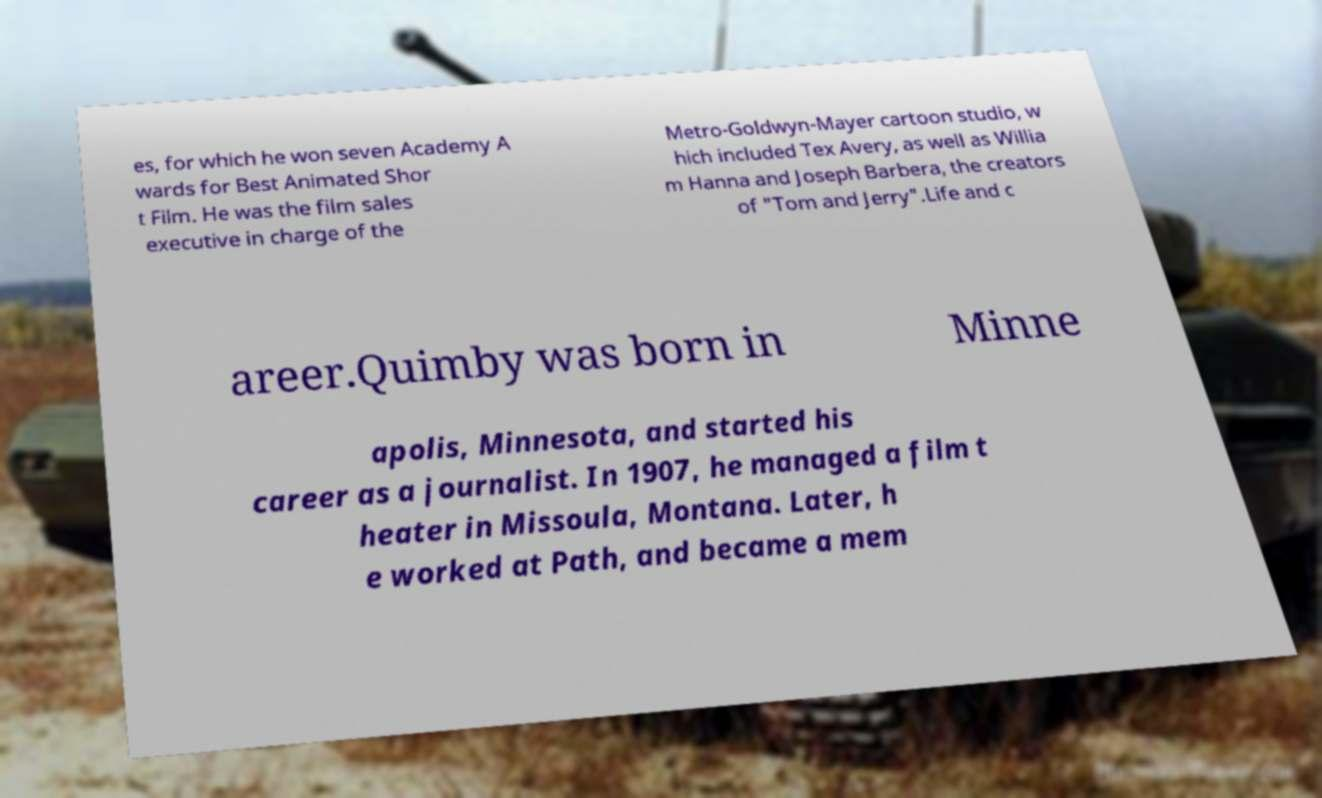Can you read and provide the text displayed in the image?This photo seems to have some interesting text. Can you extract and type it out for me? es, for which he won seven Academy A wards for Best Animated Shor t Film. He was the film sales executive in charge of the Metro-Goldwyn-Mayer cartoon studio, w hich included Tex Avery, as well as Willia m Hanna and Joseph Barbera, the creators of "Tom and Jerry".Life and c areer.Quimby was born in Minne apolis, Minnesota, and started his career as a journalist. In 1907, he managed a film t heater in Missoula, Montana. Later, h e worked at Path, and became a mem 